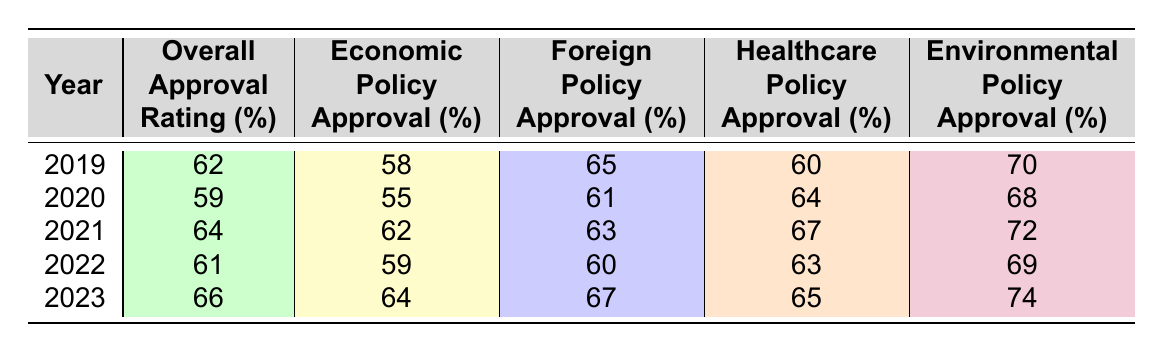What was the overall approval rating in 2021? Referring to the table, the overall approval rating for the year 2021 is 64%.
Answer: 64% Which year had the highest approval rating for healthcare policy? Looking at the healthcare policy approval ratings, the year 2023 had the highest rating of 65%.
Answer: 2023 What is the average foreign policy approval rating over the five years? The foreign policy approval ratings are 65, 61, 63, 60, and 67. Summing these values gives 65 + 61 + 63 + 60 + 67 = 316. Dividing by 5 (the number of years) gives an average of 316 / 5 = 63.2.
Answer: 63.2 Did the overall approval rating decrease from 2019 to 2020? Comparing the overall approval ratings, 2019 had 62% and 2020 had 59%, indicating a decrease.
Answer: Yes What was the change in economic policy approval from 2020 to 2023? In 2020, the economic policy approval was 55% and in 2023 it was 64%. The change is calculated as 64 - 55 = 9%.
Answer: 9% Which year's approval rating for environmental policy was closest to the overall approval rating? Comparing the environmental policy ratings with overall ratings, the closest year is 2022, where environmental approval was 69% and overall was 61%.
Answer: 2022 Which policy area showed the largest increase in approval rating from 2020 to 2023? For economic policy, the increase is 64 - 55 = 9%; for foreign policy, it’s 67 - 61 = 6%; for healthcare, it’s 65 - 64 = 1%; for environmental, it’s 74 - 68 = 6%. The largest increase is in economic policy with 9%.
Answer: Economic policy Was there a consistent increase in overall approval ratings over the five years? The overall approval ratings from 2019 to 2023 are: 62, 59, 64, 61, 66. This shows a decrease from 2019 to 2020 followed by increases in subsequent years, so it was not consistent.
Answer: No What was Rajesh Faldessai's approval rating trend for environmental policy from 2019 to 2023? The environmental policy approval ratings are: 70% (2019), 68% (2020), 72% (2021), 69% (2022), and 74% (2023). The trend shows a general increase, despite a slight dip in 2022.
Answer: Generally increasing with a dip in 2022 In which year was the foreign policy approval rating lowest? The foreign policy approval ratings are: 65% (2019), 61% (2020), 63% (2021), 60% (2022), and 67% (2023). The lowest rating is in 2020 at 61%.
Answer: 2020 